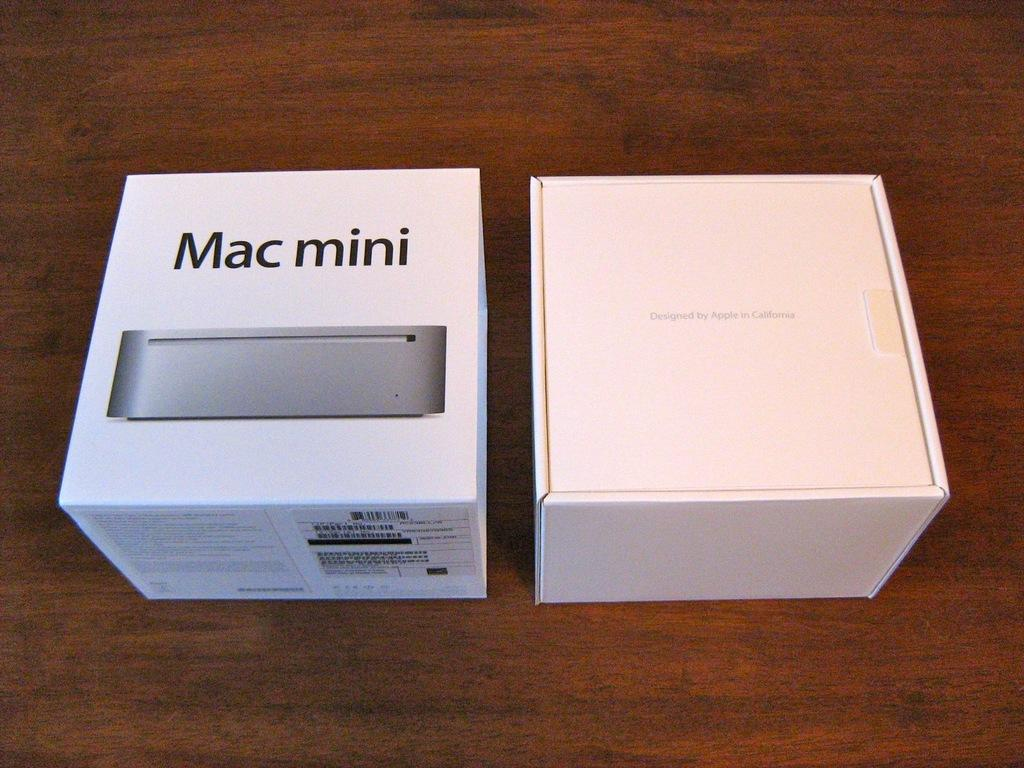<image>
Relay a brief, clear account of the picture shown. Two white boxes are sitting on a table side by side and the black writing says Mac Mini on one box. 